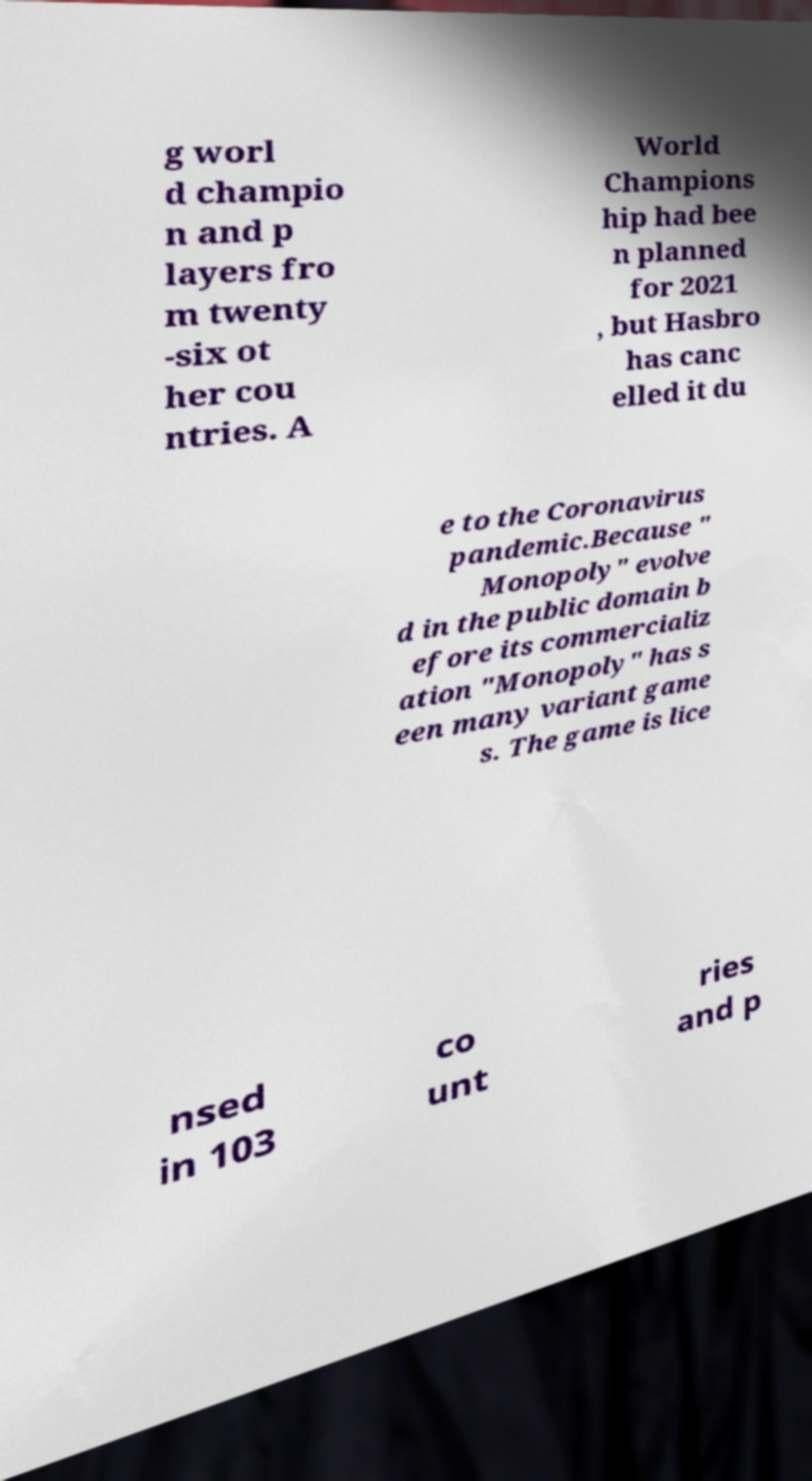Can you read and provide the text displayed in the image?This photo seems to have some interesting text. Can you extract and type it out for me? g worl d champio n and p layers fro m twenty -six ot her cou ntries. A World Champions hip had bee n planned for 2021 , but Hasbro has canc elled it du e to the Coronavirus pandemic.Because " Monopoly" evolve d in the public domain b efore its commercializ ation "Monopoly" has s een many variant game s. The game is lice nsed in 103 co unt ries and p 